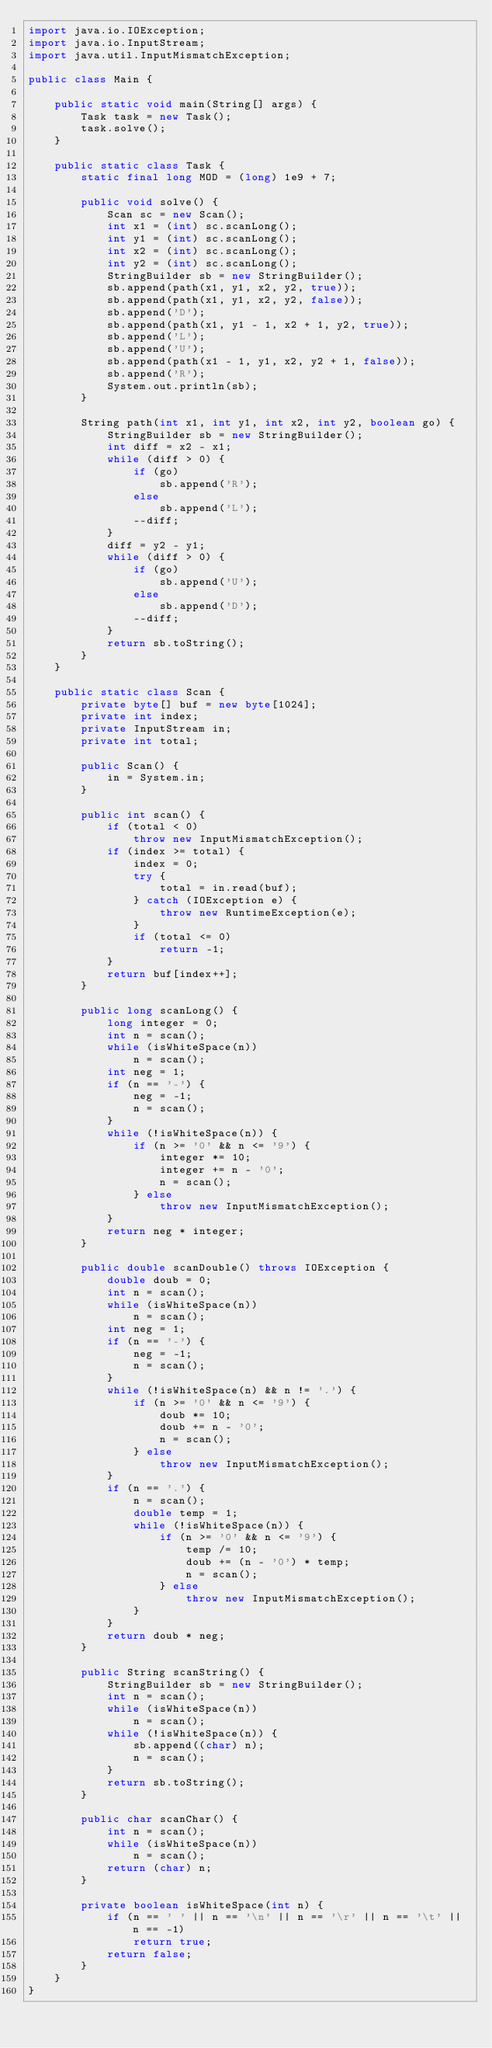<code> <loc_0><loc_0><loc_500><loc_500><_Java_>import java.io.IOException;
import java.io.InputStream;
import java.util.InputMismatchException;

public class Main {

	public static void main(String[] args) {
		Task task = new Task();
		task.solve();
	}

	public static class Task {
		static final long MOD = (long) 1e9 + 7;

		public void solve() {
			Scan sc = new Scan();
			int x1 = (int) sc.scanLong();
			int y1 = (int) sc.scanLong();
			int x2 = (int) sc.scanLong();
			int y2 = (int) sc.scanLong();
			StringBuilder sb = new StringBuilder();
			sb.append(path(x1, y1, x2, y2, true));
			sb.append(path(x1, y1, x2, y2, false));
			sb.append('D');
			sb.append(path(x1, y1 - 1, x2 + 1, y2, true));
			sb.append('L');
			sb.append('U');
			sb.append(path(x1 - 1, y1, x2, y2 + 1, false));
			sb.append('R');
			System.out.println(sb);
		}

		String path(int x1, int y1, int x2, int y2, boolean go) {
			StringBuilder sb = new StringBuilder();
			int diff = x2 - x1;
			while (diff > 0) {
				if (go)
					sb.append('R');
				else
					sb.append('L');
				--diff;
			}
			diff = y2 - y1;
			while (diff > 0) {
				if (go)
					sb.append('U');
				else
					sb.append('D');
				--diff;
			}
			return sb.toString();
		}
	}

	public static class Scan {
		private byte[] buf = new byte[1024];
		private int index;
		private InputStream in;
		private int total;

		public Scan() {
			in = System.in;
		}

		public int scan() {
			if (total < 0)
				throw new InputMismatchException();
			if (index >= total) {
				index = 0;
				try {
					total = in.read(buf);
				} catch (IOException e) {
					throw new RuntimeException(e);
				}
				if (total <= 0)
					return -1;
			}
			return buf[index++];
		}

		public long scanLong() {
			long integer = 0;
			int n = scan();
			while (isWhiteSpace(n))
				n = scan();
			int neg = 1;
			if (n == '-') {
				neg = -1;
				n = scan();
			}
			while (!isWhiteSpace(n)) {
				if (n >= '0' && n <= '9') {
					integer *= 10;
					integer += n - '0';
					n = scan();
				} else
					throw new InputMismatchException();
			}
			return neg * integer;
		}

		public double scanDouble() throws IOException {
			double doub = 0;
			int n = scan();
			while (isWhiteSpace(n))
				n = scan();
			int neg = 1;
			if (n == '-') {
				neg = -1;
				n = scan();
			}
			while (!isWhiteSpace(n) && n != '.') {
				if (n >= '0' && n <= '9') {
					doub *= 10;
					doub += n - '0';
					n = scan();
				} else
					throw new InputMismatchException();
			}
			if (n == '.') {
				n = scan();
				double temp = 1;
				while (!isWhiteSpace(n)) {
					if (n >= '0' && n <= '9') {
						temp /= 10;
						doub += (n - '0') * temp;
						n = scan();
					} else
						throw new InputMismatchException();
				}
			}
			return doub * neg;
		}

		public String scanString() {
			StringBuilder sb = new StringBuilder();
			int n = scan();
			while (isWhiteSpace(n))
				n = scan();
			while (!isWhiteSpace(n)) {
				sb.append((char) n);
				n = scan();
			}
			return sb.toString();
		}

		public char scanChar() {
			int n = scan();
			while (isWhiteSpace(n))
				n = scan();
			return (char) n;
		}

		private boolean isWhiteSpace(int n) {
			if (n == ' ' || n == '\n' || n == '\r' || n == '\t' || n == -1)
				return true;
			return false;
		}
	}
}
</code> 